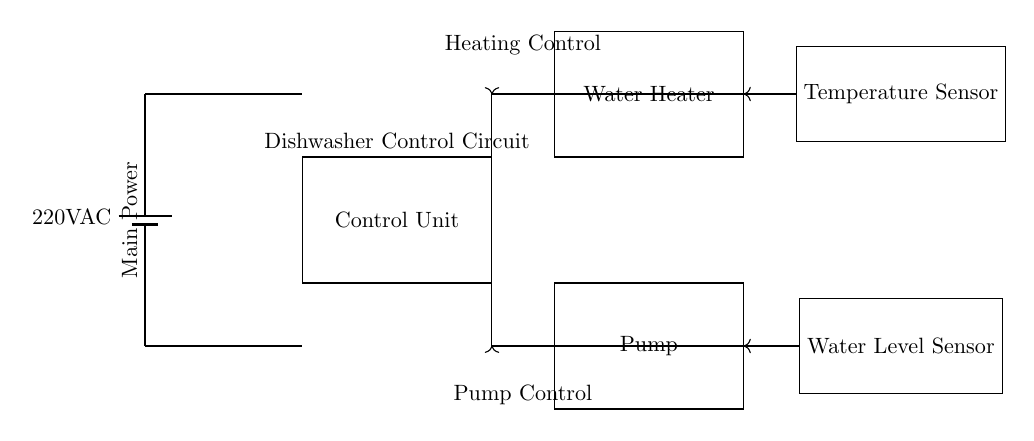What is the main power supply voltage for this circuit? The main power supply is labeled as 220V AC, which indicates the alternating current voltage supplied to the circuit.
Answer: 220V AC What two primary components control the water heating and pumping actions? The control unit, water heater, and pump are the main components involved. The control unit manages both the heater and the pump functions.
Answer: Control unit, water heater, and pump Which component measures the water temperature? The component labeled as the temperature sensor is responsible for measuring the water temperature and providing feedback to the control unit.
Answer: Temperature sensor How does the control unit receive feedback from the temperature sensor? The temperature sensor is connected to the control unit with a feedback line indicated by the arrow, which represents the flow of information from the sensor to the control unit for temperature regulation.
Answer: Feedback line What does the water level sensor do in this circuit? The water level sensor detects the water level and sends information to the control unit to ensure that the pump operates only when there is sufficient water.
Answer: Water level management Which sensors provide feedback to the control unit for operational decisions? The temperature sensor and the water level sensor both provide feedback to the control unit, allowing it to make operational decisions based on heating and water level conditions.
Answer: Temperature sensor and water level sensor 